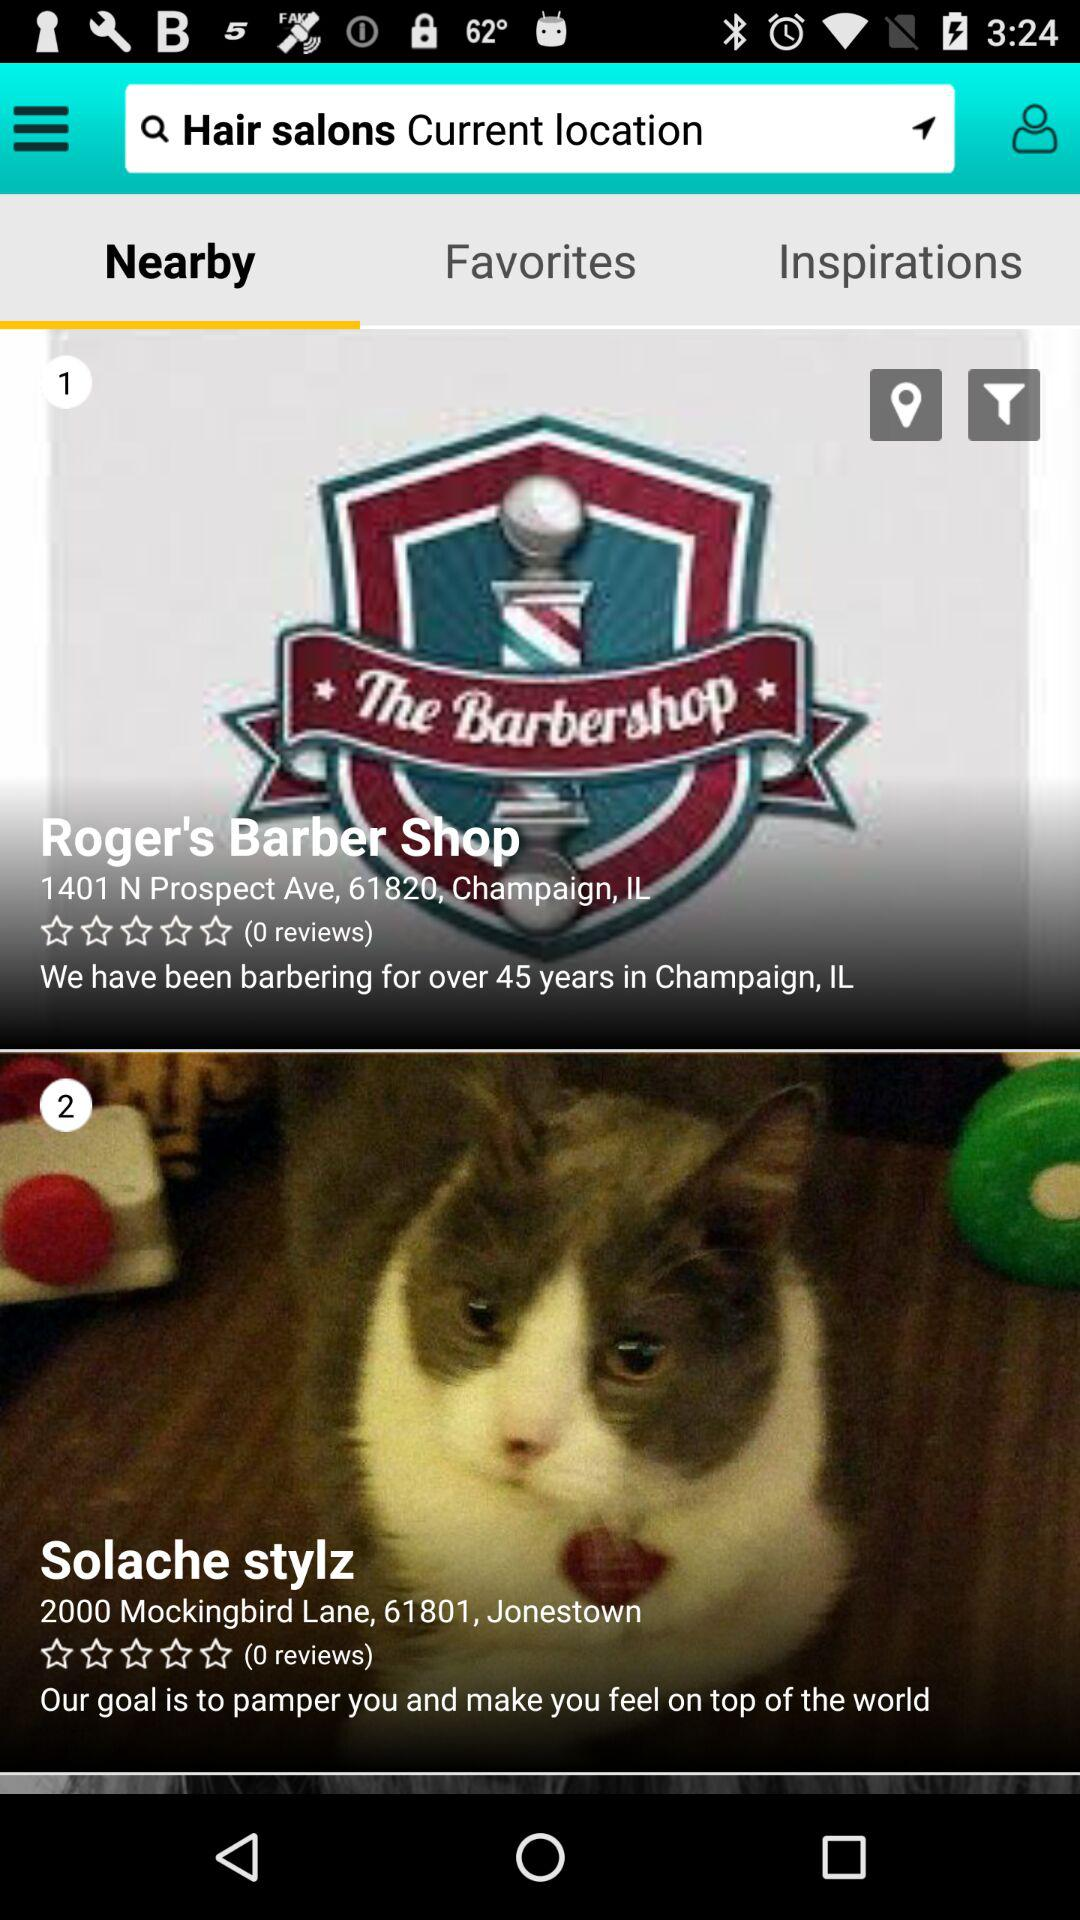Which tab is selected? The selected tab is "Nearby". 